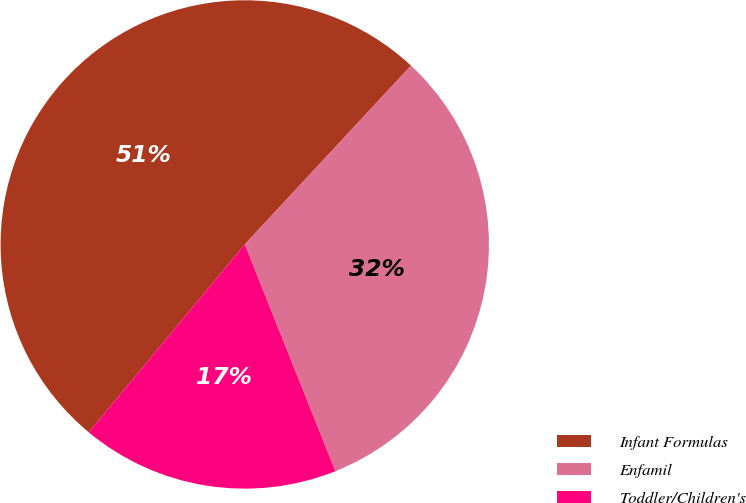<chart> <loc_0><loc_0><loc_500><loc_500><pie_chart><fcel>Infant Formulas<fcel>Enfamil<fcel>Toddler/Children's<nl><fcel>50.89%<fcel>32.03%<fcel>17.08%<nl></chart> 